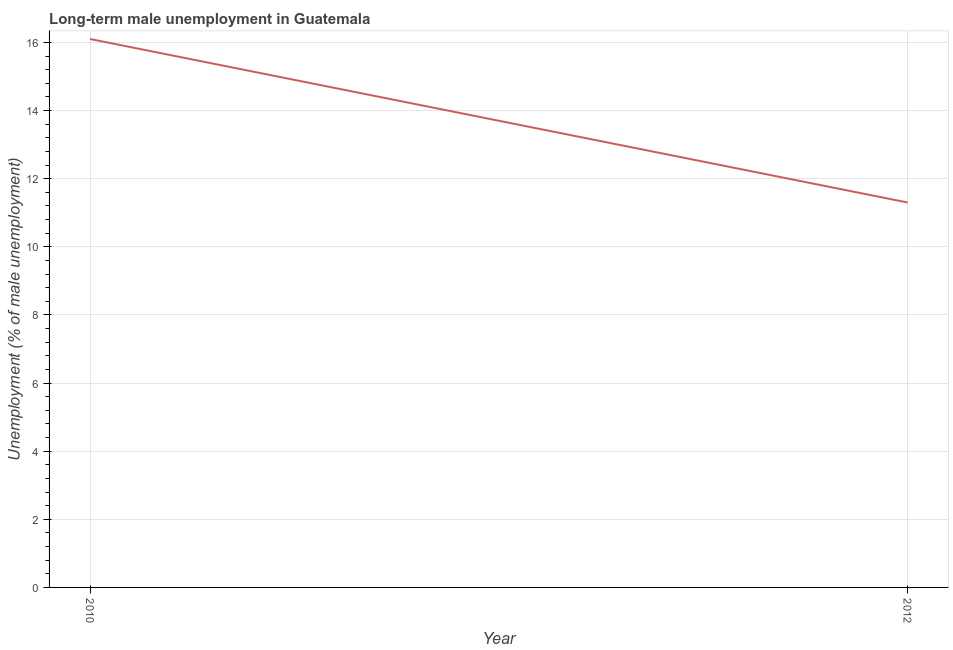What is the long-term male unemployment in 2010?
Make the answer very short. 16.1. Across all years, what is the maximum long-term male unemployment?
Your answer should be very brief. 16.1. Across all years, what is the minimum long-term male unemployment?
Give a very brief answer. 11.3. What is the sum of the long-term male unemployment?
Provide a short and direct response. 27.4. What is the difference between the long-term male unemployment in 2010 and 2012?
Give a very brief answer. 4.8. What is the average long-term male unemployment per year?
Make the answer very short. 13.7. What is the median long-term male unemployment?
Give a very brief answer. 13.7. Do a majority of the years between 2010 and 2012 (inclusive) have long-term male unemployment greater than 5.2 %?
Ensure brevity in your answer.  Yes. What is the ratio of the long-term male unemployment in 2010 to that in 2012?
Your response must be concise. 1.42. Is the long-term male unemployment in 2010 less than that in 2012?
Your answer should be very brief. No. How many lines are there?
Your answer should be compact. 1. How many years are there in the graph?
Keep it short and to the point. 2. What is the difference between two consecutive major ticks on the Y-axis?
Offer a terse response. 2. Does the graph contain grids?
Provide a short and direct response. Yes. What is the title of the graph?
Offer a very short reply. Long-term male unemployment in Guatemala. What is the label or title of the Y-axis?
Provide a succinct answer. Unemployment (% of male unemployment). What is the Unemployment (% of male unemployment) in 2010?
Give a very brief answer. 16.1. What is the Unemployment (% of male unemployment) in 2012?
Your answer should be compact. 11.3. What is the difference between the Unemployment (% of male unemployment) in 2010 and 2012?
Offer a very short reply. 4.8. What is the ratio of the Unemployment (% of male unemployment) in 2010 to that in 2012?
Keep it short and to the point. 1.43. 